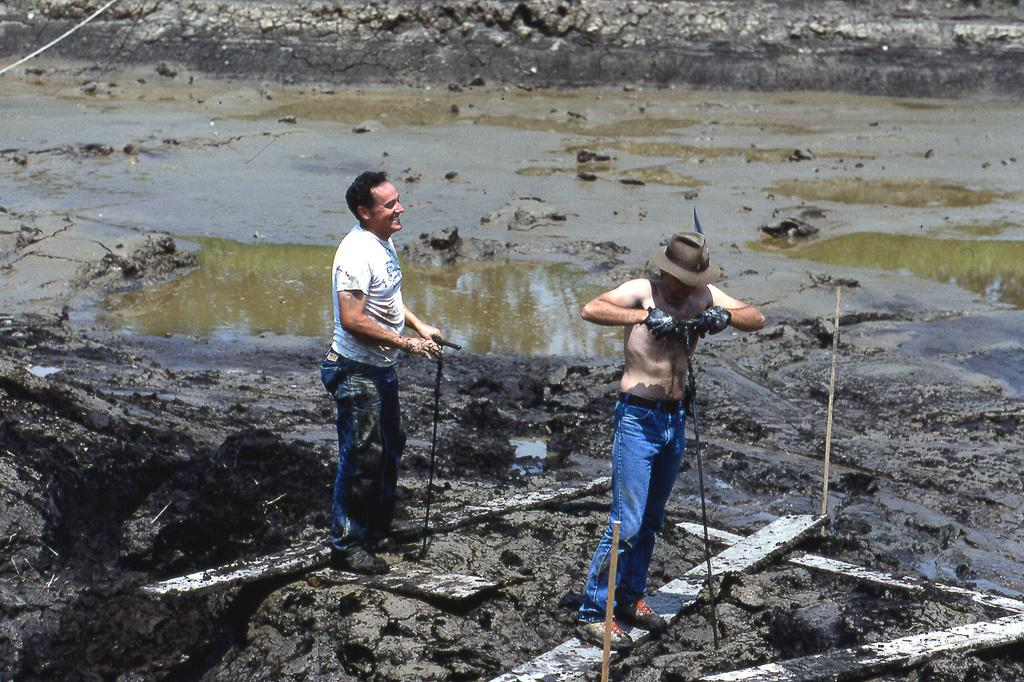How many people are in the foreground of the image? There are two men in the foreground of the image. What are the men standing on? The men are standing on a wooden plank. What are the men holding in the image? The men are holding an object. What type of environment can be seen in the image? There is water and muddy land visible in the image. What type of bushes can be seen growing near the men in the image? There are no bushes visible in the image; it features two men standing on a wooden plank with water and muddy land in the background. Can you tell me when the birth of the wooden plank occurred in the image? The image does not provide information about the birth of the wooden plank, as it is an inanimate object and not a living being. 